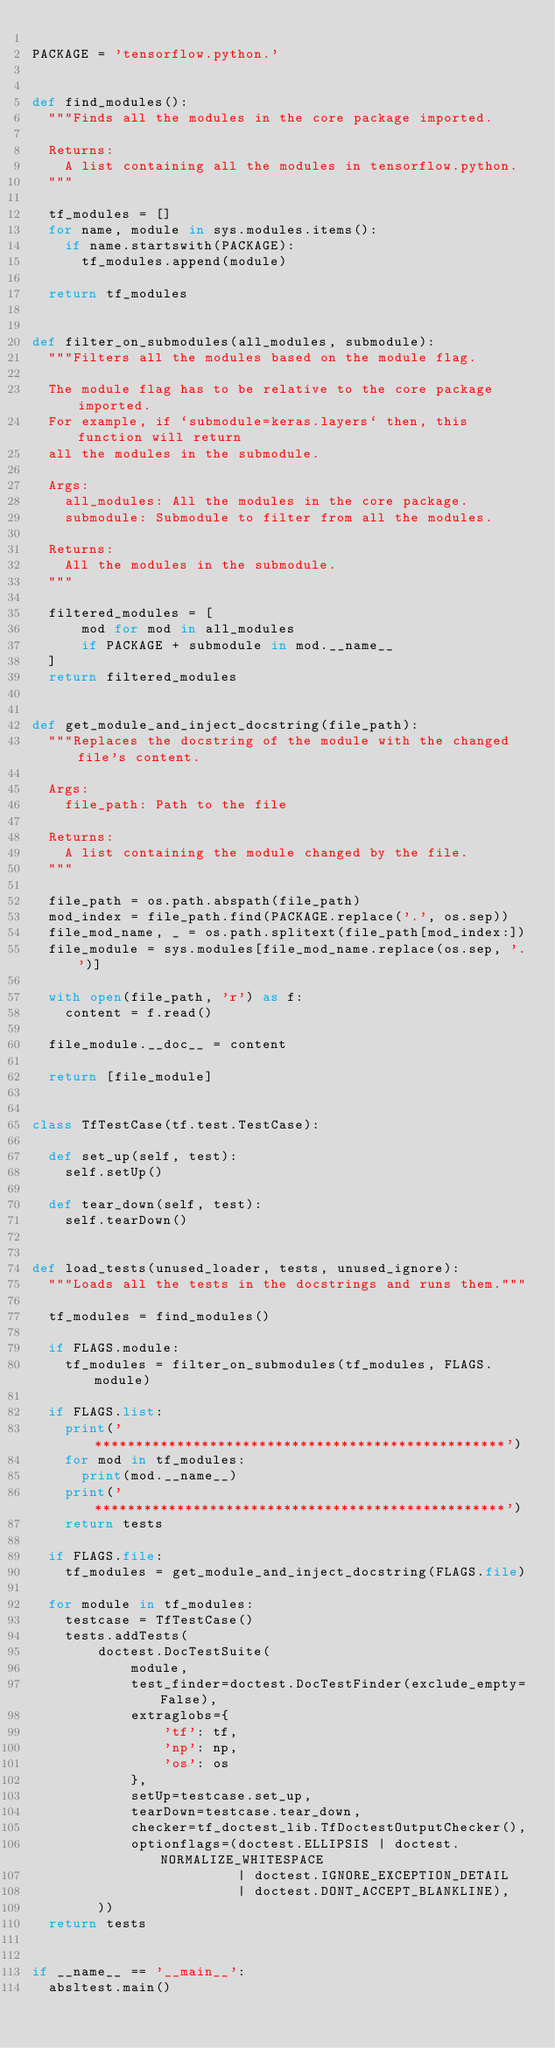<code> <loc_0><loc_0><loc_500><loc_500><_Python_>
PACKAGE = 'tensorflow.python.'


def find_modules():
  """Finds all the modules in the core package imported.

  Returns:
    A list containing all the modules in tensorflow.python.
  """

  tf_modules = []
  for name, module in sys.modules.items():
    if name.startswith(PACKAGE):
      tf_modules.append(module)

  return tf_modules


def filter_on_submodules(all_modules, submodule):
  """Filters all the modules based on the module flag.

  The module flag has to be relative to the core package imported.
  For example, if `submodule=keras.layers` then, this function will return
  all the modules in the submodule.

  Args:
    all_modules: All the modules in the core package.
    submodule: Submodule to filter from all the modules.

  Returns:
    All the modules in the submodule.
  """

  filtered_modules = [
      mod for mod in all_modules
      if PACKAGE + submodule in mod.__name__
  ]
  return filtered_modules


def get_module_and_inject_docstring(file_path):
  """Replaces the docstring of the module with the changed file's content.

  Args:
    file_path: Path to the file

  Returns:
    A list containing the module changed by the file.
  """

  file_path = os.path.abspath(file_path)
  mod_index = file_path.find(PACKAGE.replace('.', os.sep))
  file_mod_name, _ = os.path.splitext(file_path[mod_index:])
  file_module = sys.modules[file_mod_name.replace(os.sep, '.')]

  with open(file_path, 'r') as f:
    content = f.read()

  file_module.__doc__ = content

  return [file_module]


class TfTestCase(tf.test.TestCase):

  def set_up(self, test):
    self.setUp()

  def tear_down(self, test):
    self.tearDown()


def load_tests(unused_loader, tests, unused_ignore):
  """Loads all the tests in the docstrings and runs them."""

  tf_modules = find_modules()

  if FLAGS.module:
    tf_modules = filter_on_submodules(tf_modules, FLAGS.module)

  if FLAGS.list:
    print('**************************************************')
    for mod in tf_modules:
      print(mod.__name__)
    print('**************************************************')
    return tests

  if FLAGS.file:
    tf_modules = get_module_and_inject_docstring(FLAGS.file)

  for module in tf_modules:
    testcase = TfTestCase()
    tests.addTests(
        doctest.DocTestSuite(
            module,
            test_finder=doctest.DocTestFinder(exclude_empty=False),
            extraglobs={
                'tf': tf,
                'np': np,
                'os': os
            },
            setUp=testcase.set_up,
            tearDown=testcase.tear_down,
            checker=tf_doctest_lib.TfDoctestOutputChecker(),
            optionflags=(doctest.ELLIPSIS | doctest.NORMALIZE_WHITESPACE
                         | doctest.IGNORE_EXCEPTION_DETAIL
                         | doctest.DONT_ACCEPT_BLANKLINE),
        ))
  return tests


if __name__ == '__main__':
  absltest.main()
</code> 